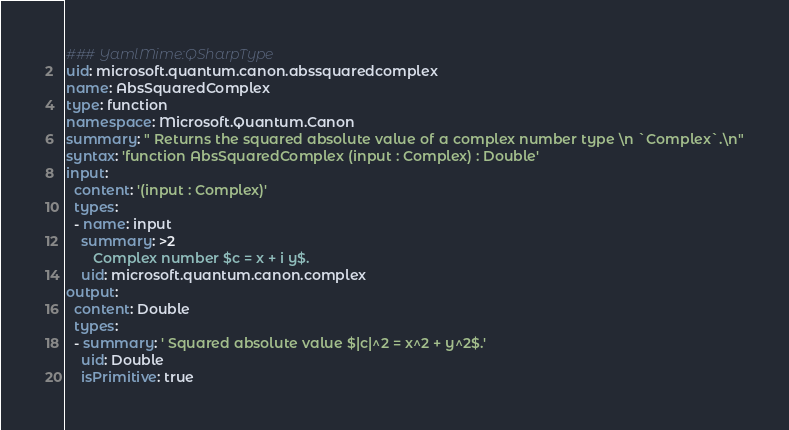Convert code to text. <code><loc_0><loc_0><loc_500><loc_500><_YAML_>### YamlMime:QSharpType
uid: microsoft.quantum.canon.abssquaredcomplex
name: AbsSquaredComplex
type: function
namespace: Microsoft.Quantum.Canon
summary: " Returns the squared absolute value of a complex number type \n `Complex`.\n"
syntax: 'function AbsSquaredComplex (input : Complex) : Double'
input:
  content: '(input : Complex)'
  types:
  - name: input
    summary: >2
       Complex number $c = x + i y$.
    uid: microsoft.quantum.canon.complex
output:
  content: Double
  types:
  - summary: ' Squared absolute value $|c|^2 = x^2 + y^2$.'
    uid: Double
    isPrimitive: true
</code> 